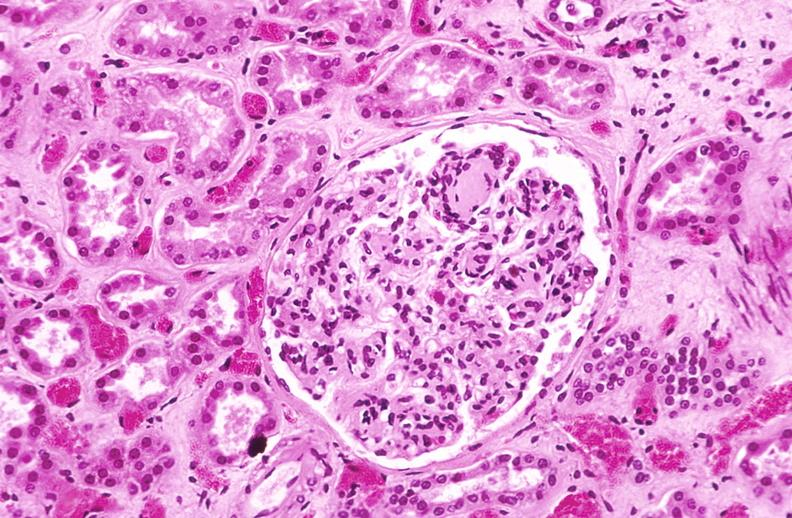where is this?
Answer the question using a single word or phrase. Urinary 